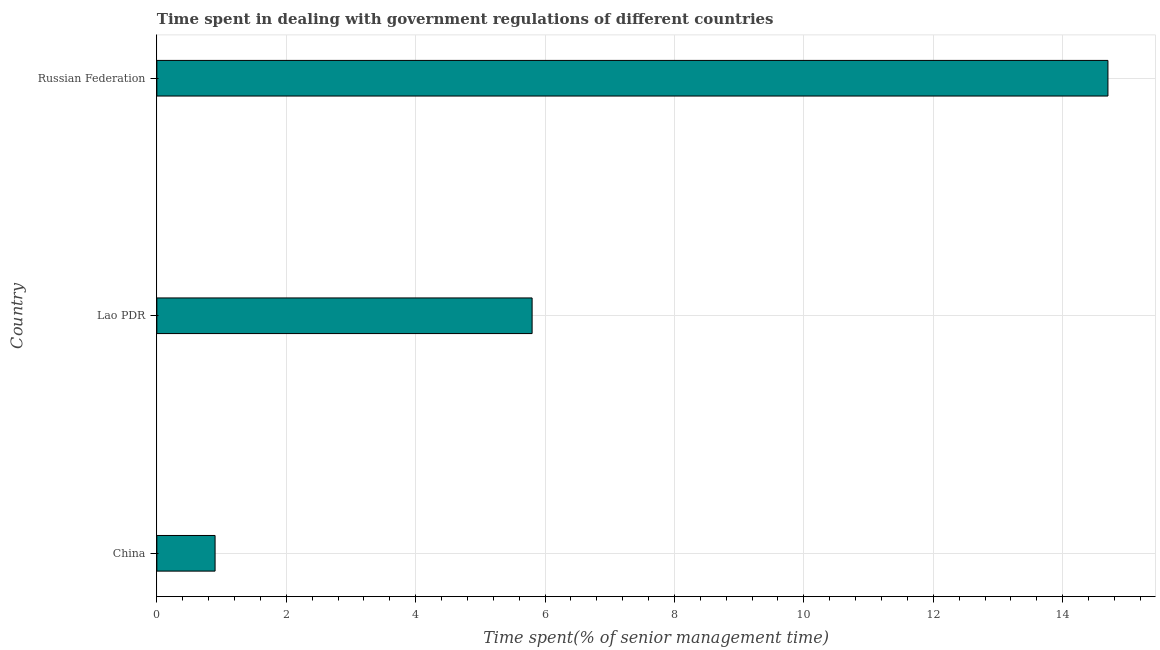Does the graph contain any zero values?
Your response must be concise. No. What is the title of the graph?
Provide a succinct answer. Time spent in dealing with government regulations of different countries. What is the label or title of the X-axis?
Offer a very short reply. Time spent(% of senior management time). What is the label or title of the Y-axis?
Provide a succinct answer. Country. Across all countries, what is the minimum time spent in dealing with government regulations?
Make the answer very short. 0.9. In which country was the time spent in dealing with government regulations maximum?
Provide a succinct answer. Russian Federation. What is the sum of the time spent in dealing with government regulations?
Provide a succinct answer. 21.4. What is the average time spent in dealing with government regulations per country?
Provide a succinct answer. 7.13. What is the median time spent in dealing with government regulations?
Ensure brevity in your answer.  5.8. In how many countries, is the time spent in dealing with government regulations greater than 8 %?
Keep it short and to the point. 1. What is the ratio of the time spent in dealing with government regulations in Lao PDR to that in Russian Federation?
Your answer should be compact. 0.4. What is the difference between the highest and the second highest time spent in dealing with government regulations?
Provide a short and direct response. 8.9. Is the sum of the time spent in dealing with government regulations in China and Lao PDR greater than the maximum time spent in dealing with government regulations across all countries?
Your response must be concise. No. Are the values on the major ticks of X-axis written in scientific E-notation?
Offer a terse response. No. What is the Time spent(% of senior management time) in Lao PDR?
Make the answer very short. 5.8. What is the difference between the Time spent(% of senior management time) in China and Lao PDR?
Offer a terse response. -4.9. What is the difference between the Time spent(% of senior management time) in Lao PDR and Russian Federation?
Your answer should be very brief. -8.9. What is the ratio of the Time spent(% of senior management time) in China to that in Lao PDR?
Provide a short and direct response. 0.15. What is the ratio of the Time spent(% of senior management time) in China to that in Russian Federation?
Offer a terse response. 0.06. What is the ratio of the Time spent(% of senior management time) in Lao PDR to that in Russian Federation?
Make the answer very short. 0.4. 